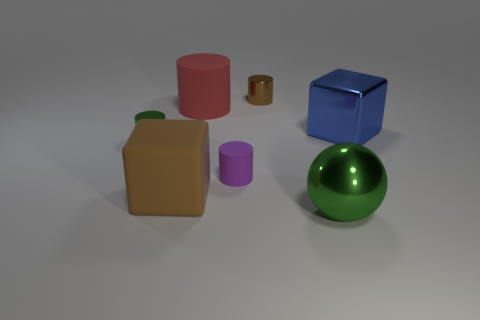Add 1 red matte objects. How many objects exist? 8 Subtract all big cylinders. How many cylinders are left? 3 Subtract all brown cylinders. How many cylinders are left? 3 Subtract all cubes. How many objects are left? 5 Subtract all gray cylinders. Subtract all gray balls. How many cylinders are left? 4 Subtract 0 blue balls. How many objects are left? 7 Subtract all metal cubes. Subtract all purple matte cylinders. How many objects are left? 5 Add 2 big metal spheres. How many big metal spheres are left? 3 Add 2 brown rubber objects. How many brown rubber objects exist? 3 